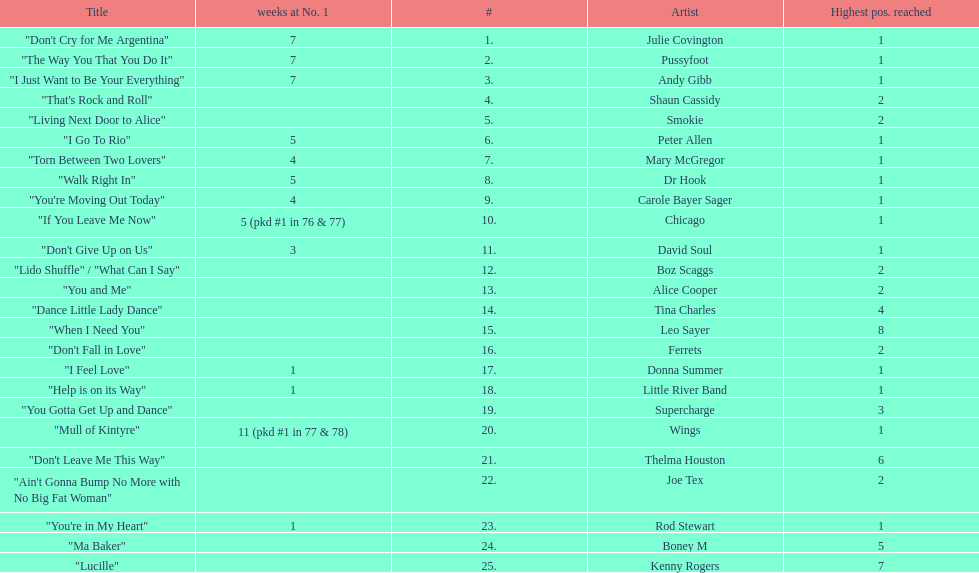How many weeks did julie covington's "don't cry for me argentina" spend at the top of australia's singles chart? 7. 